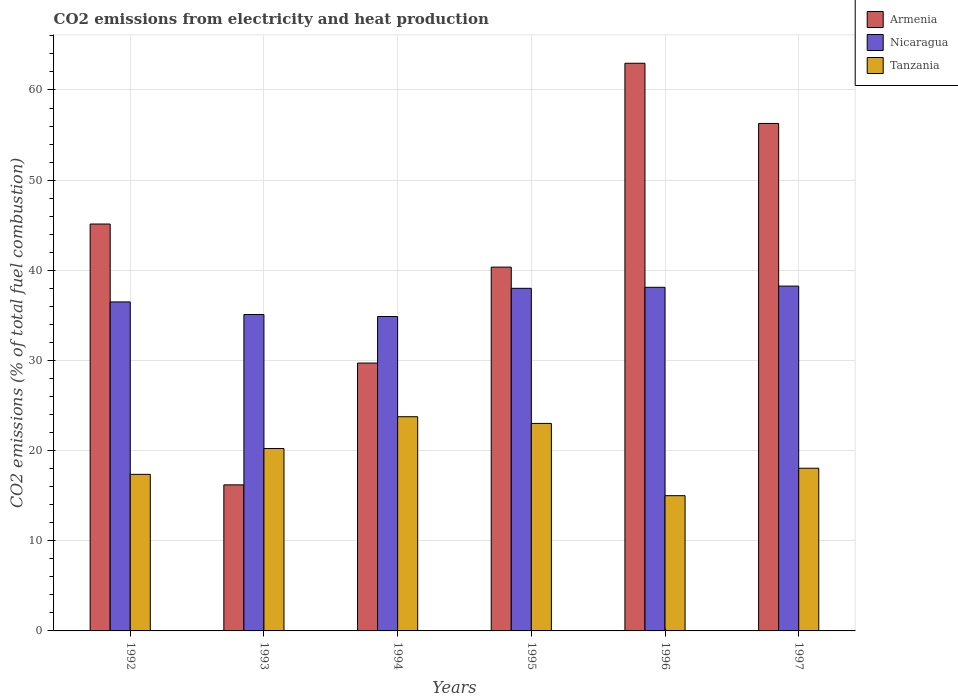How many groups of bars are there?
Make the answer very short. 6. Are the number of bars per tick equal to the number of legend labels?
Provide a short and direct response. Yes. What is the label of the 4th group of bars from the left?
Give a very brief answer. 1995. What is the amount of CO2 emitted in Nicaragua in 1992?
Offer a very short reply. 36.49. Across all years, what is the maximum amount of CO2 emitted in Nicaragua?
Your answer should be compact. 38.25. In which year was the amount of CO2 emitted in Armenia maximum?
Provide a short and direct response. 1996. What is the total amount of CO2 emitted in Tanzania in the graph?
Your answer should be compact. 117.41. What is the difference between the amount of CO2 emitted in Tanzania in 1992 and that in 1996?
Your answer should be very brief. 2.37. What is the difference between the amount of CO2 emitted in Tanzania in 1997 and the amount of CO2 emitted in Nicaragua in 1996?
Ensure brevity in your answer.  -20.07. What is the average amount of CO2 emitted in Armenia per year?
Provide a short and direct response. 41.77. In the year 1995, what is the difference between the amount of CO2 emitted in Tanzania and amount of CO2 emitted in Armenia?
Offer a very short reply. -17.34. What is the ratio of the amount of CO2 emitted in Tanzania in 1994 to that in 1995?
Give a very brief answer. 1.03. What is the difference between the highest and the second highest amount of CO2 emitted in Armenia?
Provide a short and direct response. 6.67. What is the difference between the highest and the lowest amount of CO2 emitted in Nicaragua?
Give a very brief answer. 3.37. What does the 3rd bar from the left in 1993 represents?
Your response must be concise. Tanzania. What does the 3rd bar from the right in 1996 represents?
Ensure brevity in your answer.  Armenia. How many bars are there?
Keep it short and to the point. 18. How many years are there in the graph?
Ensure brevity in your answer.  6. Are the values on the major ticks of Y-axis written in scientific E-notation?
Provide a short and direct response. No. Does the graph contain any zero values?
Keep it short and to the point. No. Where does the legend appear in the graph?
Make the answer very short. Top right. How many legend labels are there?
Your answer should be very brief. 3. What is the title of the graph?
Give a very brief answer. CO2 emissions from electricity and heat production. Does "Niger" appear as one of the legend labels in the graph?
Keep it short and to the point. No. What is the label or title of the Y-axis?
Your answer should be very brief. CO2 emissions (% of total fuel combustion). What is the CO2 emissions (% of total fuel combustion) of Armenia in 1992?
Offer a terse response. 45.13. What is the CO2 emissions (% of total fuel combustion) in Nicaragua in 1992?
Provide a short and direct response. 36.49. What is the CO2 emissions (% of total fuel combustion) of Tanzania in 1992?
Make the answer very short. 17.37. What is the CO2 emissions (% of total fuel combustion) of Nicaragua in 1993?
Ensure brevity in your answer.  35.1. What is the CO2 emissions (% of total fuel combustion) of Tanzania in 1993?
Provide a short and direct response. 20.23. What is the CO2 emissions (% of total fuel combustion) of Armenia in 1994?
Offer a very short reply. 29.71. What is the CO2 emissions (% of total fuel combustion) of Nicaragua in 1994?
Your answer should be compact. 34.87. What is the CO2 emissions (% of total fuel combustion) of Tanzania in 1994?
Make the answer very short. 23.76. What is the CO2 emissions (% of total fuel combustion) in Armenia in 1995?
Offer a very short reply. 40.35. What is the CO2 emissions (% of total fuel combustion) in Tanzania in 1995?
Ensure brevity in your answer.  23.02. What is the CO2 emissions (% of total fuel combustion) of Armenia in 1996?
Give a very brief answer. 62.96. What is the CO2 emissions (% of total fuel combustion) in Nicaragua in 1996?
Ensure brevity in your answer.  38.11. What is the CO2 emissions (% of total fuel combustion) of Tanzania in 1996?
Give a very brief answer. 15. What is the CO2 emissions (% of total fuel combustion) in Armenia in 1997?
Keep it short and to the point. 56.29. What is the CO2 emissions (% of total fuel combustion) in Nicaragua in 1997?
Offer a very short reply. 38.25. What is the CO2 emissions (% of total fuel combustion) in Tanzania in 1997?
Ensure brevity in your answer.  18.05. Across all years, what is the maximum CO2 emissions (% of total fuel combustion) of Armenia?
Offer a very short reply. 62.96. Across all years, what is the maximum CO2 emissions (% of total fuel combustion) of Nicaragua?
Make the answer very short. 38.25. Across all years, what is the maximum CO2 emissions (% of total fuel combustion) of Tanzania?
Provide a succinct answer. 23.76. Across all years, what is the minimum CO2 emissions (% of total fuel combustion) in Armenia?
Your response must be concise. 16.2. Across all years, what is the minimum CO2 emissions (% of total fuel combustion) in Nicaragua?
Your response must be concise. 34.87. What is the total CO2 emissions (% of total fuel combustion) of Armenia in the graph?
Your answer should be very brief. 250.64. What is the total CO2 emissions (% of total fuel combustion) in Nicaragua in the graph?
Provide a succinct answer. 220.82. What is the total CO2 emissions (% of total fuel combustion) in Tanzania in the graph?
Keep it short and to the point. 117.41. What is the difference between the CO2 emissions (% of total fuel combustion) in Armenia in 1992 and that in 1993?
Your response must be concise. 28.93. What is the difference between the CO2 emissions (% of total fuel combustion) of Nicaragua in 1992 and that in 1993?
Make the answer very short. 1.4. What is the difference between the CO2 emissions (% of total fuel combustion) in Tanzania in 1992 and that in 1993?
Offer a terse response. -2.87. What is the difference between the CO2 emissions (% of total fuel combustion) of Armenia in 1992 and that in 1994?
Offer a terse response. 15.42. What is the difference between the CO2 emissions (% of total fuel combustion) of Nicaragua in 1992 and that in 1994?
Offer a terse response. 1.62. What is the difference between the CO2 emissions (% of total fuel combustion) of Tanzania in 1992 and that in 1994?
Your answer should be compact. -6.39. What is the difference between the CO2 emissions (% of total fuel combustion) in Armenia in 1992 and that in 1995?
Your response must be concise. 4.78. What is the difference between the CO2 emissions (% of total fuel combustion) of Nicaragua in 1992 and that in 1995?
Your response must be concise. -1.51. What is the difference between the CO2 emissions (% of total fuel combustion) of Tanzania in 1992 and that in 1995?
Provide a succinct answer. -5.65. What is the difference between the CO2 emissions (% of total fuel combustion) of Armenia in 1992 and that in 1996?
Provide a short and direct response. -17.83. What is the difference between the CO2 emissions (% of total fuel combustion) of Nicaragua in 1992 and that in 1996?
Offer a terse response. -1.62. What is the difference between the CO2 emissions (% of total fuel combustion) of Tanzania in 1992 and that in 1996?
Provide a short and direct response. 2.37. What is the difference between the CO2 emissions (% of total fuel combustion) in Armenia in 1992 and that in 1997?
Give a very brief answer. -11.16. What is the difference between the CO2 emissions (% of total fuel combustion) of Nicaragua in 1992 and that in 1997?
Your response must be concise. -1.75. What is the difference between the CO2 emissions (% of total fuel combustion) of Tanzania in 1992 and that in 1997?
Your response must be concise. -0.68. What is the difference between the CO2 emissions (% of total fuel combustion) in Armenia in 1993 and that in 1994?
Offer a terse response. -13.51. What is the difference between the CO2 emissions (% of total fuel combustion) in Nicaragua in 1993 and that in 1994?
Provide a short and direct response. 0.22. What is the difference between the CO2 emissions (% of total fuel combustion) in Tanzania in 1993 and that in 1994?
Provide a succinct answer. -3.53. What is the difference between the CO2 emissions (% of total fuel combustion) in Armenia in 1993 and that in 1995?
Offer a terse response. -24.15. What is the difference between the CO2 emissions (% of total fuel combustion) of Nicaragua in 1993 and that in 1995?
Your answer should be compact. -2.9. What is the difference between the CO2 emissions (% of total fuel combustion) in Tanzania in 1993 and that in 1995?
Your response must be concise. -2.78. What is the difference between the CO2 emissions (% of total fuel combustion) in Armenia in 1993 and that in 1996?
Your answer should be very brief. -46.76. What is the difference between the CO2 emissions (% of total fuel combustion) in Nicaragua in 1993 and that in 1996?
Ensure brevity in your answer.  -3.02. What is the difference between the CO2 emissions (% of total fuel combustion) in Tanzania in 1993 and that in 1996?
Your answer should be compact. 5.23. What is the difference between the CO2 emissions (% of total fuel combustion) of Armenia in 1993 and that in 1997?
Your response must be concise. -40.09. What is the difference between the CO2 emissions (% of total fuel combustion) of Nicaragua in 1993 and that in 1997?
Ensure brevity in your answer.  -3.15. What is the difference between the CO2 emissions (% of total fuel combustion) of Tanzania in 1993 and that in 1997?
Your answer should be compact. 2.19. What is the difference between the CO2 emissions (% of total fuel combustion) in Armenia in 1994 and that in 1995?
Provide a succinct answer. -10.64. What is the difference between the CO2 emissions (% of total fuel combustion) of Nicaragua in 1994 and that in 1995?
Provide a succinct answer. -3.13. What is the difference between the CO2 emissions (% of total fuel combustion) of Tanzania in 1994 and that in 1995?
Make the answer very short. 0.74. What is the difference between the CO2 emissions (% of total fuel combustion) of Armenia in 1994 and that in 1996?
Keep it short and to the point. -33.25. What is the difference between the CO2 emissions (% of total fuel combustion) in Nicaragua in 1994 and that in 1996?
Provide a succinct answer. -3.24. What is the difference between the CO2 emissions (% of total fuel combustion) in Tanzania in 1994 and that in 1996?
Make the answer very short. 8.76. What is the difference between the CO2 emissions (% of total fuel combustion) of Armenia in 1994 and that in 1997?
Give a very brief answer. -26.58. What is the difference between the CO2 emissions (% of total fuel combustion) in Nicaragua in 1994 and that in 1997?
Your answer should be compact. -3.37. What is the difference between the CO2 emissions (% of total fuel combustion) of Tanzania in 1994 and that in 1997?
Give a very brief answer. 5.71. What is the difference between the CO2 emissions (% of total fuel combustion) of Armenia in 1995 and that in 1996?
Your response must be concise. -22.61. What is the difference between the CO2 emissions (% of total fuel combustion) in Nicaragua in 1995 and that in 1996?
Your answer should be compact. -0.11. What is the difference between the CO2 emissions (% of total fuel combustion) in Tanzania in 1995 and that in 1996?
Offer a terse response. 8.02. What is the difference between the CO2 emissions (% of total fuel combustion) in Armenia in 1995 and that in 1997?
Keep it short and to the point. -15.94. What is the difference between the CO2 emissions (% of total fuel combustion) in Nicaragua in 1995 and that in 1997?
Ensure brevity in your answer.  -0.25. What is the difference between the CO2 emissions (% of total fuel combustion) in Tanzania in 1995 and that in 1997?
Provide a short and direct response. 4.97. What is the difference between the CO2 emissions (% of total fuel combustion) of Armenia in 1996 and that in 1997?
Your answer should be compact. 6.67. What is the difference between the CO2 emissions (% of total fuel combustion) in Nicaragua in 1996 and that in 1997?
Your answer should be very brief. -0.13. What is the difference between the CO2 emissions (% of total fuel combustion) of Tanzania in 1996 and that in 1997?
Make the answer very short. -3.05. What is the difference between the CO2 emissions (% of total fuel combustion) of Armenia in 1992 and the CO2 emissions (% of total fuel combustion) of Nicaragua in 1993?
Your response must be concise. 10.03. What is the difference between the CO2 emissions (% of total fuel combustion) of Armenia in 1992 and the CO2 emissions (% of total fuel combustion) of Tanzania in 1993?
Offer a terse response. 24.9. What is the difference between the CO2 emissions (% of total fuel combustion) in Nicaragua in 1992 and the CO2 emissions (% of total fuel combustion) in Tanzania in 1993?
Provide a short and direct response. 16.26. What is the difference between the CO2 emissions (% of total fuel combustion) in Armenia in 1992 and the CO2 emissions (% of total fuel combustion) in Nicaragua in 1994?
Offer a very short reply. 10.26. What is the difference between the CO2 emissions (% of total fuel combustion) of Armenia in 1992 and the CO2 emissions (% of total fuel combustion) of Tanzania in 1994?
Your answer should be compact. 21.37. What is the difference between the CO2 emissions (% of total fuel combustion) in Nicaragua in 1992 and the CO2 emissions (% of total fuel combustion) in Tanzania in 1994?
Give a very brief answer. 12.74. What is the difference between the CO2 emissions (% of total fuel combustion) in Armenia in 1992 and the CO2 emissions (% of total fuel combustion) in Nicaragua in 1995?
Make the answer very short. 7.13. What is the difference between the CO2 emissions (% of total fuel combustion) of Armenia in 1992 and the CO2 emissions (% of total fuel combustion) of Tanzania in 1995?
Provide a succinct answer. 22.12. What is the difference between the CO2 emissions (% of total fuel combustion) in Nicaragua in 1992 and the CO2 emissions (% of total fuel combustion) in Tanzania in 1995?
Your answer should be very brief. 13.48. What is the difference between the CO2 emissions (% of total fuel combustion) of Armenia in 1992 and the CO2 emissions (% of total fuel combustion) of Nicaragua in 1996?
Provide a succinct answer. 7.02. What is the difference between the CO2 emissions (% of total fuel combustion) in Armenia in 1992 and the CO2 emissions (% of total fuel combustion) in Tanzania in 1996?
Offer a very short reply. 30.13. What is the difference between the CO2 emissions (% of total fuel combustion) in Nicaragua in 1992 and the CO2 emissions (% of total fuel combustion) in Tanzania in 1996?
Your answer should be compact. 21.49. What is the difference between the CO2 emissions (% of total fuel combustion) in Armenia in 1992 and the CO2 emissions (% of total fuel combustion) in Nicaragua in 1997?
Provide a short and direct response. 6.89. What is the difference between the CO2 emissions (% of total fuel combustion) in Armenia in 1992 and the CO2 emissions (% of total fuel combustion) in Tanzania in 1997?
Provide a succinct answer. 27.09. What is the difference between the CO2 emissions (% of total fuel combustion) in Nicaragua in 1992 and the CO2 emissions (% of total fuel combustion) in Tanzania in 1997?
Offer a very short reply. 18.45. What is the difference between the CO2 emissions (% of total fuel combustion) of Armenia in 1993 and the CO2 emissions (% of total fuel combustion) of Nicaragua in 1994?
Your answer should be very brief. -18.67. What is the difference between the CO2 emissions (% of total fuel combustion) of Armenia in 1993 and the CO2 emissions (% of total fuel combustion) of Tanzania in 1994?
Offer a terse response. -7.56. What is the difference between the CO2 emissions (% of total fuel combustion) of Nicaragua in 1993 and the CO2 emissions (% of total fuel combustion) of Tanzania in 1994?
Ensure brevity in your answer.  11.34. What is the difference between the CO2 emissions (% of total fuel combustion) in Armenia in 1993 and the CO2 emissions (% of total fuel combustion) in Nicaragua in 1995?
Provide a short and direct response. -21.8. What is the difference between the CO2 emissions (% of total fuel combustion) in Armenia in 1993 and the CO2 emissions (% of total fuel combustion) in Tanzania in 1995?
Offer a very short reply. -6.82. What is the difference between the CO2 emissions (% of total fuel combustion) of Nicaragua in 1993 and the CO2 emissions (% of total fuel combustion) of Tanzania in 1995?
Give a very brief answer. 12.08. What is the difference between the CO2 emissions (% of total fuel combustion) of Armenia in 1993 and the CO2 emissions (% of total fuel combustion) of Nicaragua in 1996?
Your response must be concise. -21.91. What is the difference between the CO2 emissions (% of total fuel combustion) of Nicaragua in 1993 and the CO2 emissions (% of total fuel combustion) of Tanzania in 1996?
Make the answer very short. 20.1. What is the difference between the CO2 emissions (% of total fuel combustion) in Armenia in 1993 and the CO2 emissions (% of total fuel combustion) in Nicaragua in 1997?
Ensure brevity in your answer.  -22.05. What is the difference between the CO2 emissions (% of total fuel combustion) in Armenia in 1993 and the CO2 emissions (% of total fuel combustion) in Tanzania in 1997?
Your answer should be compact. -1.85. What is the difference between the CO2 emissions (% of total fuel combustion) of Nicaragua in 1993 and the CO2 emissions (% of total fuel combustion) of Tanzania in 1997?
Your response must be concise. 17.05. What is the difference between the CO2 emissions (% of total fuel combustion) in Armenia in 1994 and the CO2 emissions (% of total fuel combustion) in Nicaragua in 1995?
Make the answer very short. -8.29. What is the difference between the CO2 emissions (% of total fuel combustion) in Armenia in 1994 and the CO2 emissions (% of total fuel combustion) in Tanzania in 1995?
Ensure brevity in your answer.  6.69. What is the difference between the CO2 emissions (% of total fuel combustion) of Nicaragua in 1994 and the CO2 emissions (% of total fuel combustion) of Tanzania in 1995?
Make the answer very short. 11.86. What is the difference between the CO2 emissions (% of total fuel combustion) in Armenia in 1994 and the CO2 emissions (% of total fuel combustion) in Nicaragua in 1996?
Ensure brevity in your answer.  -8.4. What is the difference between the CO2 emissions (% of total fuel combustion) of Armenia in 1994 and the CO2 emissions (% of total fuel combustion) of Tanzania in 1996?
Provide a succinct answer. 14.71. What is the difference between the CO2 emissions (% of total fuel combustion) of Nicaragua in 1994 and the CO2 emissions (% of total fuel combustion) of Tanzania in 1996?
Offer a terse response. 19.87. What is the difference between the CO2 emissions (% of total fuel combustion) in Armenia in 1994 and the CO2 emissions (% of total fuel combustion) in Nicaragua in 1997?
Your answer should be compact. -8.54. What is the difference between the CO2 emissions (% of total fuel combustion) of Armenia in 1994 and the CO2 emissions (% of total fuel combustion) of Tanzania in 1997?
Offer a terse response. 11.66. What is the difference between the CO2 emissions (% of total fuel combustion) in Nicaragua in 1994 and the CO2 emissions (% of total fuel combustion) in Tanzania in 1997?
Offer a terse response. 16.83. What is the difference between the CO2 emissions (% of total fuel combustion) of Armenia in 1995 and the CO2 emissions (% of total fuel combustion) of Nicaragua in 1996?
Keep it short and to the point. 2.24. What is the difference between the CO2 emissions (% of total fuel combustion) of Armenia in 1995 and the CO2 emissions (% of total fuel combustion) of Tanzania in 1996?
Give a very brief answer. 25.35. What is the difference between the CO2 emissions (% of total fuel combustion) of Armenia in 1995 and the CO2 emissions (% of total fuel combustion) of Nicaragua in 1997?
Keep it short and to the point. 2.11. What is the difference between the CO2 emissions (% of total fuel combustion) in Armenia in 1995 and the CO2 emissions (% of total fuel combustion) in Tanzania in 1997?
Keep it short and to the point. 22.31. What is the difference between the CO2 emissions (% of total fuel combustion) of Nicaragua in 1995 and the CO2 emissions (% of total fuel combustion) of Tanzania in 1997?
Your answer should be compact. 19.95. What is the difference between the CO2 emissions (% of total fuel combustion) in Armenia in 1996 and the CO2 emissions (% of total fuel combustion) in Nicaragua in 1997?
Your answer should be very brief. 24.72. What is the difference between the CO2 emissions (% of total fuel combustion) of Armenia in 1996 and the CO2 emissions (% of total fuel combustion) of Tanzania in 1997?
Provide a short and direct response. 44.92. What is the difference between the CO2 emissions (% of total fuel combustion) in Nicaragua in 1996 and the CO2 emissions (% of total fuel combustion) in Tanzania in 1997?
Provide a short and direct response. 20.07. What is the average CO2 emissions (% of total fuel combustion) of Armenia per year?
Make the answer very short. 41.77. What is the average CO2 emissions (% of total fuel combustion) in Nicaragua per year?
Give a very brief answer. 36.8. What is the average CO2 emissions (% of total fuel combustion) in Tanzania per year?
Offer a very short reply. 19.57. In the year 1992, what is the difference between the CO2 emissions (% of total fuel combustion) of Armenia and CO2 emissions (% of total fuel combustion) of Nicaragua?
Make the answer very short. 8.64. In the year 1992, what is the difference between the CO2 emissions (% of total fuel combustion) of Armenia and CO2 emissions (% of total fuel combustion) of Tanzania?
Offer a terse response. 27.77. In the year 1992, what is the difference between the CO2 emissions (% of total fuel combustion) in Nicaragua and CO2 emissions (% of total fuel combustion) in Tanzania?
Make the answer very short. 19.13. In the year 1993, what is the difference between the CO2 emissions (% of total fuel combustion) of Armenia and CO2 emissions (% of total fuel combustion) of Nicaragua?
Provide a short and direct response. -18.9. In the year 1993, what is the difference between the CO2 emissions (% of total fuel combustion) of Armenia and CO2 emissions (% of total fuel combustion) of Tanzania?
Keep it short and to the point. -4.03. In the year 1993, what is the difference between the CO2 emissions (% of total fuel combustion) of Nicaragua and CO2 emissions (% of total fuel combustion) of Tanzania?
Your answer should be compact. 14.86. In the year 1994, what is the difference between the CO2 emissions (% of total fuel combustion) in Armenia and CO2 emissions (% of total fuel combustion) in Nicaragua?
Your response must be concise. -5.16. In the year 1994, what is the difference between the CO2 emissions (% of total fuel combustion) in Armenia and CO2 emissions (% of total fuel combustion) in Tanzania?
Your answer should be compact. 5.95. In the year 1994, what is the difference between the CO2 emissions (% of total fuel combustion) of Nicaragua and CO2 emissions (% of total fuel combustion) of Tanzania?
Offer a terse response. 11.12. In the year 1995, what is the difference between the CO2 emissions (% of total fuel combustion) of Armenia and CO2 emissions (% of total fuel combustion) of Nicaragua?
Provide a succinct answer. 2.35. In the year 1995, what is the difference between the CO2 emissions (% of total fuel combustion) of Armenia and CO2 emissions (% of total fuel combustion) of Tanzania?
Ensure brevity in your answer.  17.34. In the year 1995, what is the difference between the CO2 emissions (% of total fuel combustion) of Nicaragua and CO2 emissions (% of total fuel combustion) of Tanzania?
Ensure brevity in your answer.  14.98. In the year 1996, what is the difference between the CO2 emissions (% of total fuel combustion) in Armenia and CO2 emissions (% of total fuel combustion) in Nicaragua?
Offer a very short reply. 24.85. In the year 1996, what is the difference between the CO2 emissions (% of total fuel combustion) of Armenia and CO2 emissions (% of total fuel combustion) of Tanzania?
Make the answer very short. 47.96. In the year 1996, what is the difference between the CO2 emissions (% of total fuel combustion) in Nicaragua and CO2 emissions (% of total fuel combustion) in Tanzania?
Ensure brevity in your answer.  23.11. In the year 1997, what is the difference between the CO2 emissions (% of total fuel combustion) in Armenia and CO2 emissions (% of total fuel combustion) in Nicaragua?
Provide a succinct answer. 18.04. In the year 1997, what is the difference between the CO2 emissions (% of total fuel combustion) in Armenia and CO2 emissions (% of total fuel combustion) in Tanzania?
Give a very brief answer. 38.24. In the year 1997, what is the difference between the CO2 emissions (% of total fuel combustion) in Nicaragua and CO2 emissions (% of total fuel combustion) in Tanzania?
Provide a succinct answer. 20.2. What is the ratio of the CO2 emissions (% of total fuel combustion) of Armenia in 1992 to that in 1993?
Offer a terse response. 2.79. What is the ratio of the CO2 emissions (% of total fuel combustion) of Nicaragua in 1992 to that in 1993?
Make the answer very short. 1.04. What is the ratio of the CO2 emissions (% of total fuel combustion) of Tanzania in 1992 to that in 1993?
Keep it short and to the point. 0.86. What is the ratio of the CO2 emissions (% of total fuel combustion) of Armenia in 1992 to that in 1994?
Provide a short and direct response. 1.52. What is the ratio of the CO2 emissions (% of total fuel combustion) of Nicaragua in 1992 to that in 1994?
Give a very brief answer. 1.05. What is the ratio of the CO2 emissions (% of total fuel combustion) in Tanzania in 1992 to that in 1994?
Your response must be concise. 0.73. What is the ratio of the CO2 emissions (% of total fuel combustion) in Armenia in 1992 to that in 1995?
Offer a terse response. 1.12. What is the ratio of the CO2 emissions (% of total fuel combustion) in Nicaragua in 1992 to that in 1995?
Ensure brevity in your answer.  0.96. What is the ratio of the CO2 emissions (% of total fuel combustion) of Tanzania in 1992 to that in 1995?
Make the answer very short. 0.75. What is the ratio of the CO2 emissions (% of total fuel combustion) of Armenia in 1992 to that in 1996?
Make the answer very short. 0.72. What is the ratio of the CO2 emissions (% of total fuel combustion) of Nicaragua in 1992 to that in 1996?
Provide a short and direct response. 0.96. What is the ratio of the CO2 emissions (% of total fuel combustion) in Tanzania in 1992 to that in 1996?
Your response must be concise. 1.16. What is the ratio of the CO2 emissions (% of total fuel combustion) of Armenia in 1992 to that in 1997?
Give a very brief answer. 0.8. What is the ratio of the CO2 emissions (% of total fuel combustion) in Nicaragua in 1992 to that in 1997?
Make the answer very short. 0.95. What is the ratio of the CO2 emissions (% of total fuel combustion) of Tanzania in 1992 to that in 1997?
Ensure brevity in your answer.  0.96. What is the ratio of the CO2 emissions (% of total fuel combustion) of Armenia in 1993 to that in 1994?
Provide a short and direct response. 0.55. What is the ratio of the CO2 emissions (% of total fuel combustion) of Nicaragua in 1993 to that in 1994?
Provide a short and direct response. 1.01. What is the ratio of the CO2 emissions (% of total fuel combustion) in Tanzania in 1993 to that in 1994?
Your answer should be compact. 0.85. What is the ratio of the CO2 emissions (% of total fuel combustion) in Armenia in 1993 to that in 1995?
Your answer should be compact. 0.4. What is the ratio of the CO2 emissions (% of total fuel combustion) in Nicaragua in 1993 to that in 1995?
Provide a succinct answer. 0.92. What is the ratio of the CO2 emissions (% of total fuel combustion) of Tanzania in 1993 to that in 1995?
Provide a short and direct response. 0.88. What is the ratio of the CO2 emissions (% of total fuel combustion) of Armenia in 1993 to that in 1996?
Give a very brief answer. 0.26. What is the ratio of the CO2 emissions (% of total fuel combustion) of Nicaragua in 1993 to that in 1996?
Provide a short and direct response. 0.92. What is the ratio of the CO2 emissions (% of total fuel combustion) of Tanzania in 1993 to that in 1996?
Keep it short and to the point. 1.35. What is the ratio of the CO2 emissions (% of total fuel combustion) in Armenia in 1993 to that in 1997?
Provide a succinct answer. 0.29. What is the ratio of the CO2 emissions (% of total fuel combustion) in Nicaragua in 1993 to that in 1997?
Your answer should be compact. 0.92. What is the ratio of the CO2 emissions (% of total fuel combustion) of Tanzania in 1993 to that in 1997?
Your response must be concise. 1.12. What is the ratio of the CO2 emissions (% of total fuel combustion) in Armenia in 1994 to that in 1995?
Ensure brevity in your answer.  0.74. What is the ratio of the CO2 emissions (% of total fuel combustion) in Nicaragua in 1994 to that in 1995?
Ensure brevity in your answer.  0.92. What is the ratio of the CO2 emissions (% of total fuel combustion) in Tanzania in 1994 to that in 1995?
Ensure brevity in your answer.  1.03. What is the ratio of the CO2 emissions (% of total fuel combustion) of Armenia in 1994 to that in 1996?
Ensure brevity in your answer.  0.47. What is the ratio of the CO2 emissions (% of total fuel combustion) of Nicaragua in 1994 to that in 1996?
Your answer should be compact. 0.92. What is the ratio of the CO2 emissions (% of total fuel combustion) in Tanzania in 1994 to that in 1996?
Keep it short and to the point. 1.58. What is the ratio of the CO2 emissions (% of total fuel combustion) in Armenia in 1994 to that in 1997?
Provide a succinct answer. 0.53. What is the ratio of the CO2 emissions (% of total fuel combustion) in Nicaragua in 1994 to that in 1997?
Keep it short and to the point. 0.91. What is the ratio of the CO2 emissions (% of total fuel combustion) in Tanzania in 1994 to that in 1997?
Offer a terse response. 1.32. What is the ratio of the CO2 emissions (% of total fuel combustion) of Armenia in 1995 to that in 1996?
Your response must be concise. 0.64. What is the ratio of the CO2 emissions (% of total fuel combustion) in Nicaragua in 1995 to that in 1996?
Ensure brevity in your answer.  1. What is the ratio of the CO2 emissions (% of total fuel combustion) in Tanzania in 1995 to that in 1996?
Offer a terse response. 1.53. What is the ratio of the CO2 emissions (% of total fuel combustion) in Armenia in 1995 to that in 1997?
Provide a short and direct response. 0.72. What is the ratio of the CO2 emissions (% of total fuel combustion) of Nicaragua in 1995 to that in 1997?
Give a very brief answer. 0.99. What is the ratio of the CO2 emissions (% of total fuel combustion) in Tanzania in 1995 to that in 1997?
Offer a terse response. 1.28. What is the ratio of the CO2 emissions (% of total fuel combustion) in Armenia in 1996 to that in 1997?
Offer a very short reply. 1.12. What is the ratio of the CO2 emissions (% of total fuel combustion) of Nicaragua in 1996 to that in 1997?
Your answer should be very brief. 1. What is the ratio of the CO2 emissions (% of total fuel combustion) of Tanzania in 1996 to that in 1997?
Provide a succinct answer. 0.83. What is the difference between the highest and the second highest CO2 emissions (% of total fuel combustion) in Armenia?
Make the answer very short. 6.67. What is the difference between the highest and the second highest CO2 emissions (% of total fuel combustion) of Nicaragua?
Offer a very short reply. 0.13. What is the difference between the highest and the second highest CO2 emissions (% of total fuel combustion) in Tanzania?
Give a very brief answer. 0.74. What is the difference between the highest and the lowest CO2 emissions (% of total fuel combustion) in Armenia?
Keep it short and to the point. 46.76. What is the difference between the highest and the lowest CO2 emissions (% of total fuel combustion) in Nicaragua?
Offer a terse response. 3.37. What is the difference between the highest and the lowest CO2 emissions (% of total fuel combustion) in Tanzania?
Ensure brevity in your answer.  8.76. 